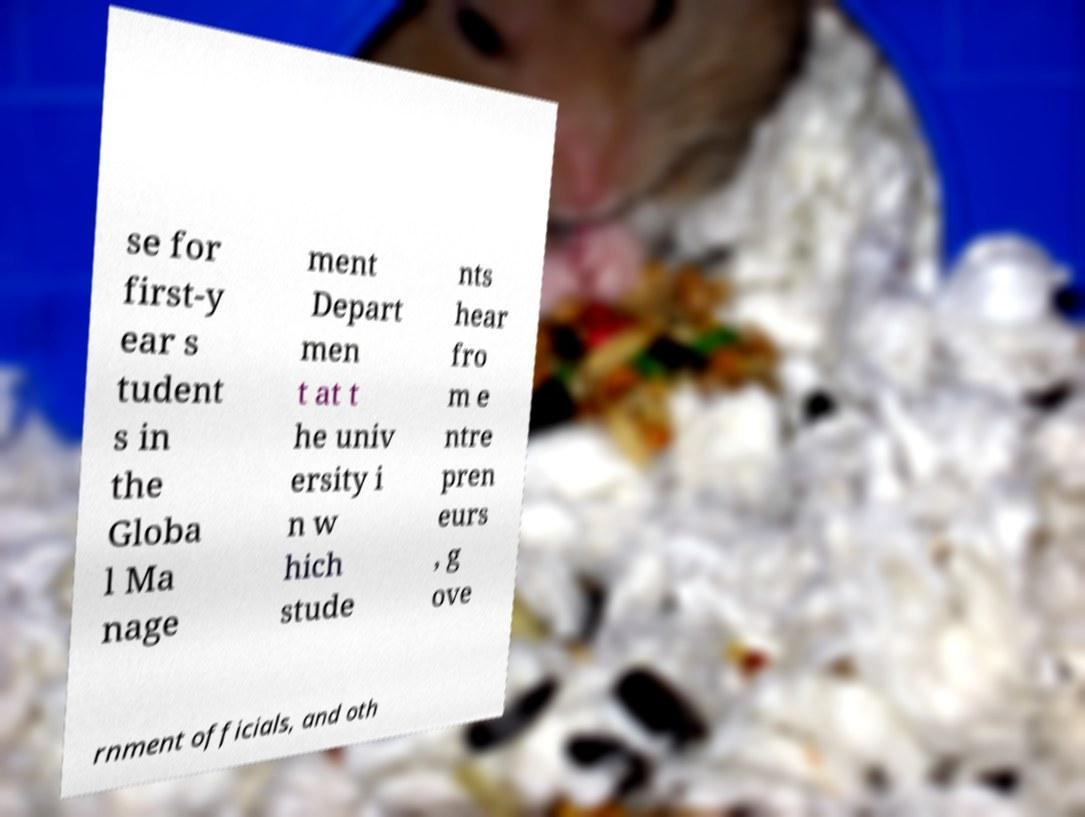Can you read and provide the text displayed in the image?This photo seems to have some interesting text. Can you extract and type it out for me? se for first-y ear s tudent s in the Globa l Ma nage ment Depart men t at t he univ ersity i n w hich stude nts hear fro m e ntre pren eurs , g ove rnment officials, and oth 